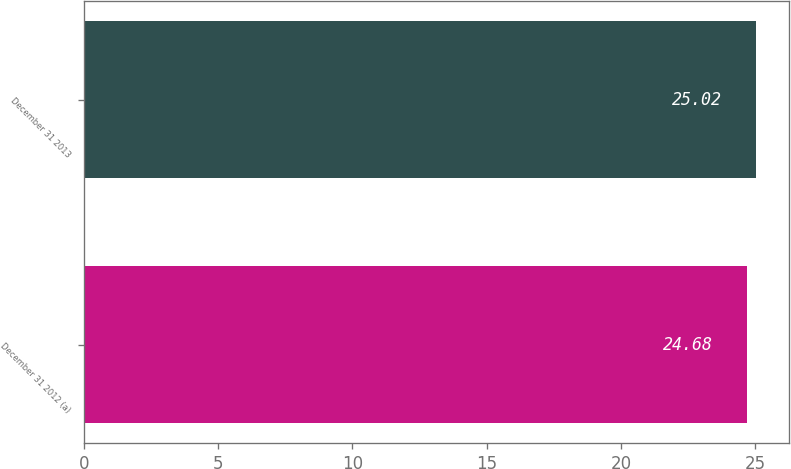<chart> <loc_0><loc_0><loc_500><loc_500><bar_chart><fcel>December 31 2012 (a)<fcel>December 31 2013<nl><fcel>24.68<fcel>25.02<nl></chart> 